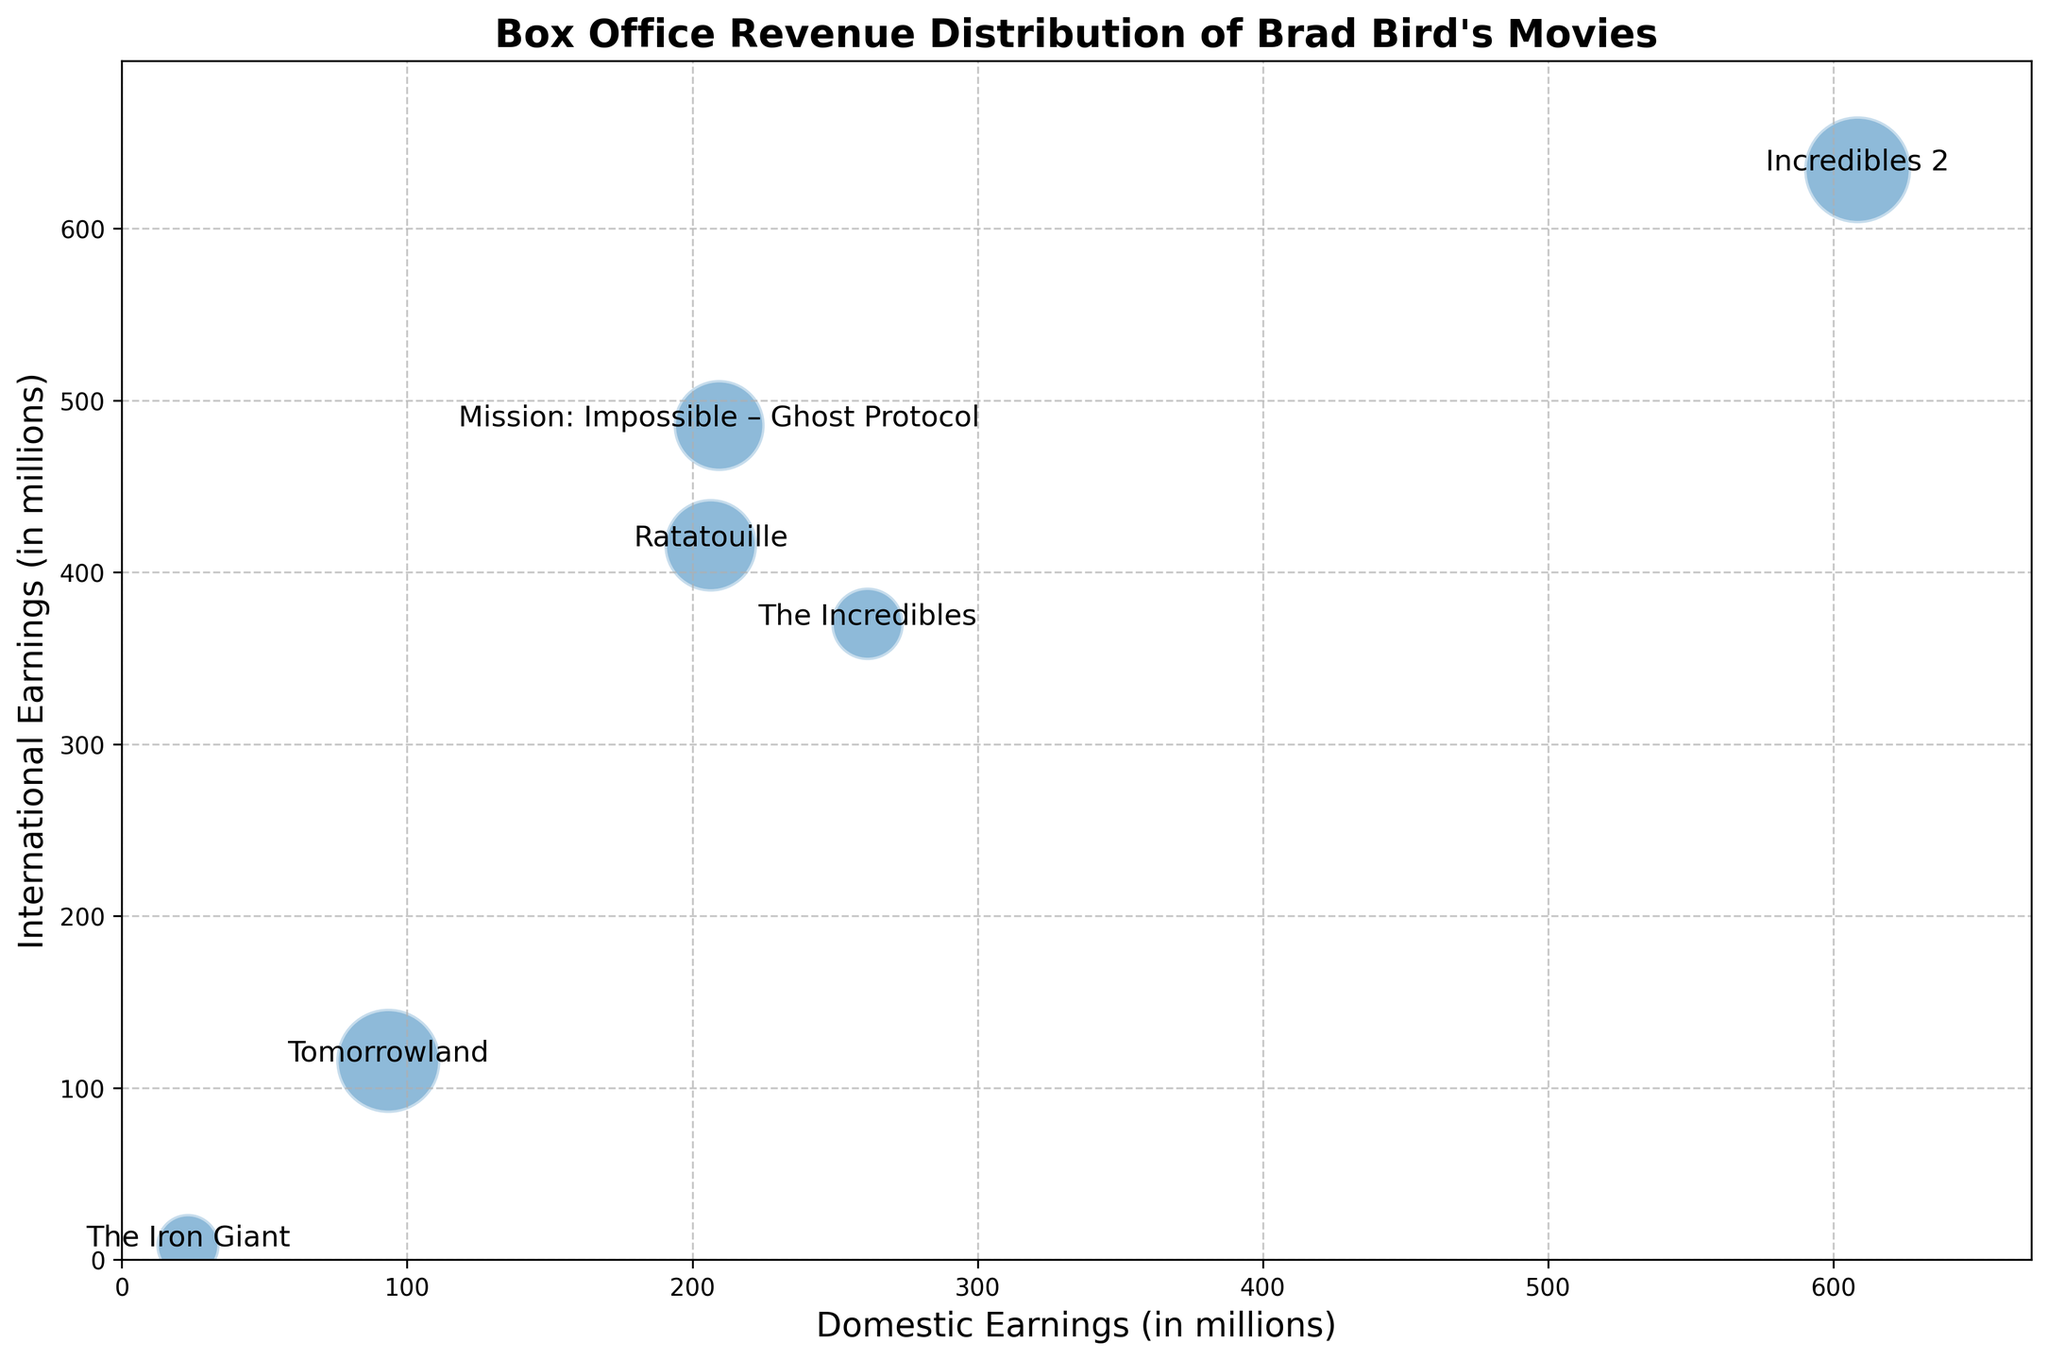What is the difference between the domestic and international earnings of "The Incredibles"? To find the difference between the domestic and international earnings of "The Incredibles", look at the plot annotations. The domestic earnings are 261.44 million, and the international earnings are 370 million. Subtract the domestic from the international earnings: 370 - 261.44 = 108.56.
Answer: 108.56 million Which movie has the highest combined earnings from both domestic and international box offices? To determine which movie has the highest combined earnings, sum the domestic and international earnings for each movie and compare the totals. The movie with the highest combined earnings is "Incredibles 2" with 608.58 + 634.20 = 1242.78 million.
Answer: Incredibles 2 What is the average budget of Brad Bird's movies? To find the average budget, sum the budgets of all the movies and divide by the number of movies. The budgets are 70, 92, 150, 145, 190, and 200. The total budget is 847. Dividing by 6 movies: 847 / 6 ≈ 141.17.
Answer: 141.17 million Which movie has the smallest bubble size, indicating the smallest budget? On the bubble chart, the smallest bubble represents the smallest budget. The smallest bubble is "The Iron Giant" with a budget of 70 million.
Answer: The Iron Giant Which movie earned more internationally than domestically while having a larger bubble size than "Mission: Impossible – Ghost Protocol"? Compare the international and domestic earnings and bubble sizes of the movies. "Ratatouille" earned more internationally (415.70 million) than domestically (206.45 million) and has a larger bubble size than "Mission: Impossible – Ghost Protocol".
Answer: Ratatouille 